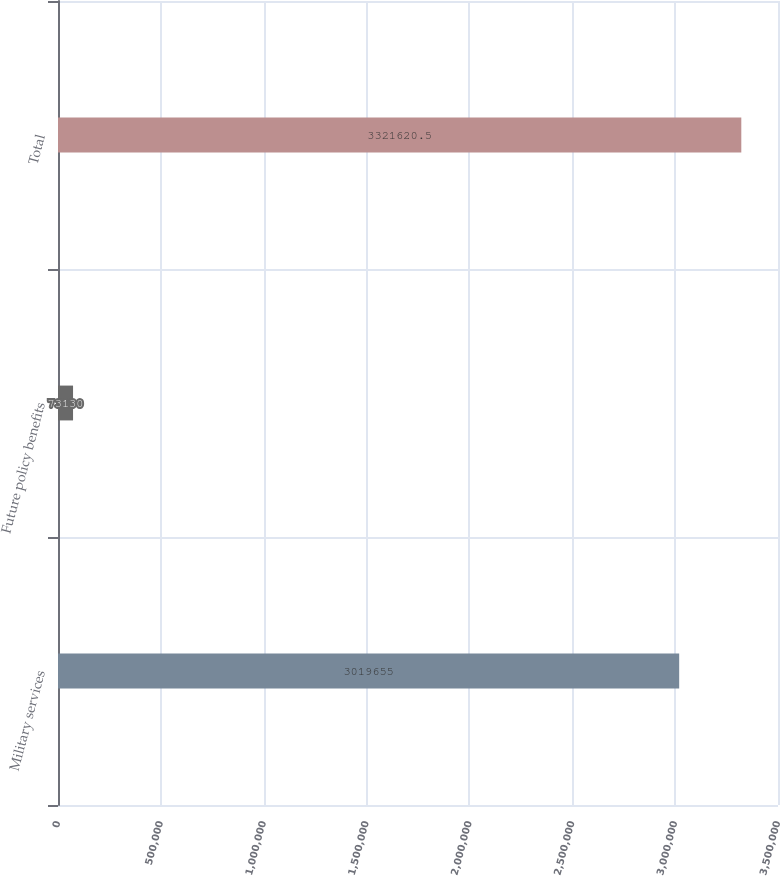Convert chart. <chart><loc_0><loc_0><loc_500><loc_500><bar_chart><fcel>Military services<fcel>Future policy benefits<fcel>Total<nl><fcel>3.01966e+06<fcel>73130<fcel>3.32162e+06<nl></chart> 